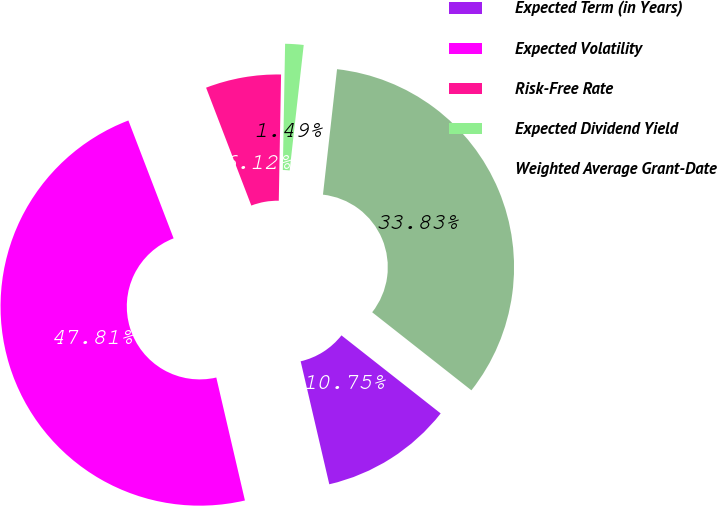Convert chart. <chart><loc_0><loc_0><loc_500><loc_500><pie_chart><fcel>Expected Term (in Years)<fcel>Expected Volatility<fcel>Risk-Free Rate<fcel>Expected Dividend Yield<fcel>Weighted Average Grant-Date<nl><fcel>10.75%<fcel>47.81%<fcel>6.12%<fcel>1.49%<fcel>33.83%<nl></chart> 